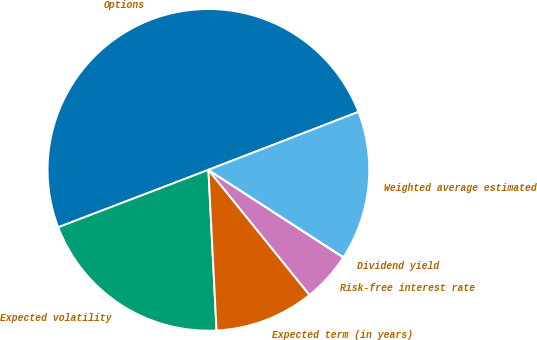Convert chart to OTSL. <chart><loc_0><loc_0><loc_500><loc_500><pie_chart><fcel>Options<fcel>Expected volatility<fcel>Expected term (in years)<fcel>Risk-free interest rate<fcel>Dividend yield<fcel>Weighted average estimated<nl><fcel>49.94%<fcel>19.99%<fcel>10.01%<fcel>5.02%<fcel>0.03%<fcel>15.0%<nl></chart> 